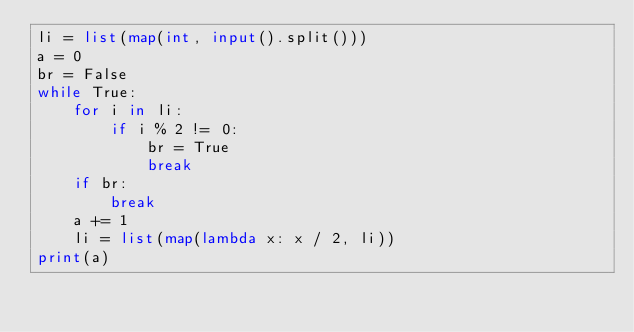Convert code to text. <code><loc_0><loc_0><loc_500><loc_500><_Python_>li = list(map(int, input().split()))
a = 0
br = False
while True:
    for i in li:
        if i % 2 != 0:
            br = True
            break
    if br:
        break
    a += 1
    li = list(map(lambda x: x / 2, li))
print(a)</code> 